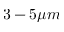Convert formula to latex. <formula><loc_0><loc_0><loc_500><loc_500>3 - 5 \mu m</formula> 